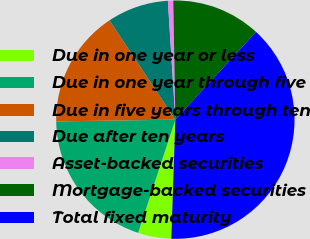Convert chart to OTSL. <chart><loc_0><loc_0><loc_500><loc_500><pie_chart><fcel>Due in one year or less<fcel>Due in one year through five<fcel>Due in five years through ten<fcel>Due after ten years<fcel>Asset-backed securities<fcel>Mortgage-backed securities<fcel>Total fixed maturity<nl><fcel>4.52%<fcel>19.71%<fcel>15.91%<fcel>8.32%<fcel>0.72%<fcel>12.12%<fcel>38.7%<nl></chart> 